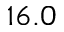<formula> <loc_0><loc_0><loc_500><loc_500>1 6 . 0</formula> 